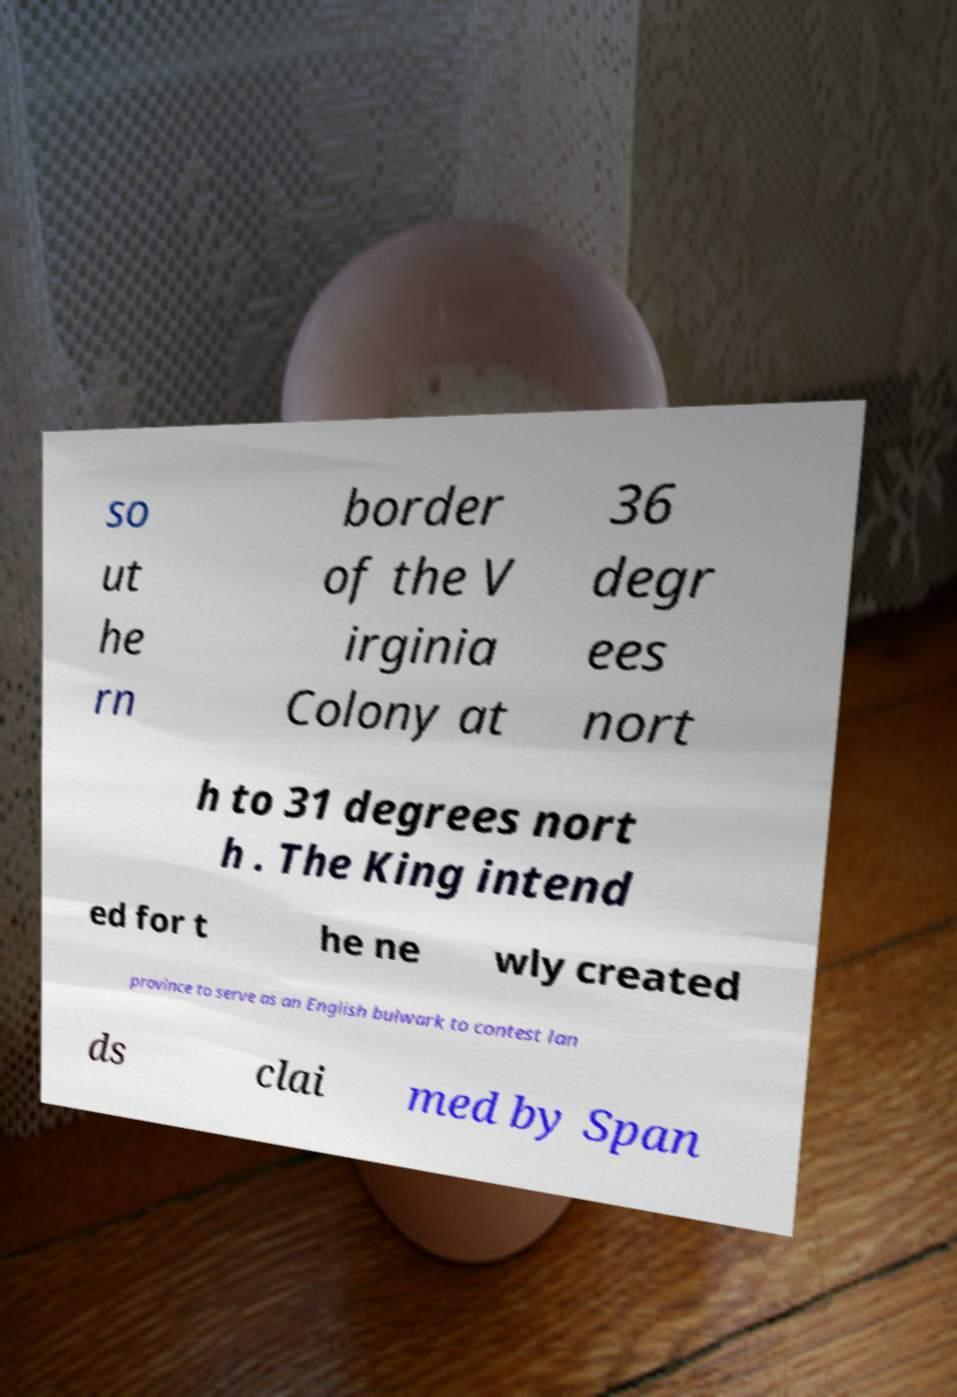What messages or text are displayed in this image? I need them in a readable, typed format. so ut he rn border of the V irginia Colony at 36 degr ees nort h to 31 degrees nort h . The King intend ed for t he ne wly created province to serve as an English bulwark to contest lan ds clai med by Span 